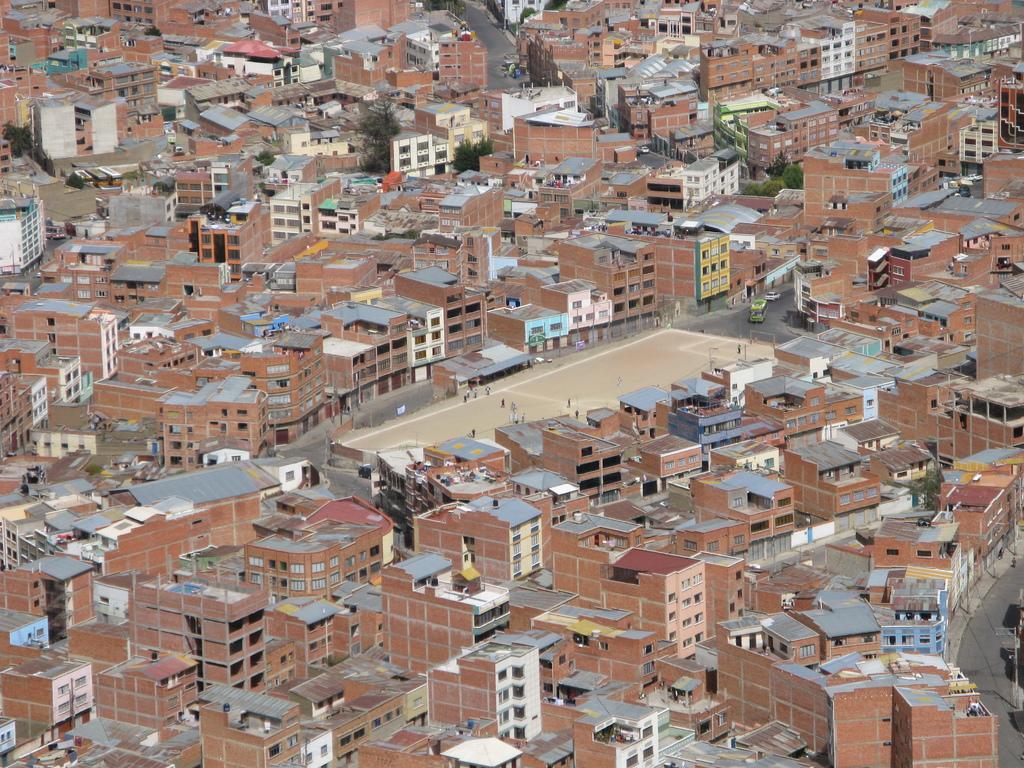Could you give a brief overview of what you see in this image? In this picture I can see few buildings and trees and looks like few people playing in the ground. 